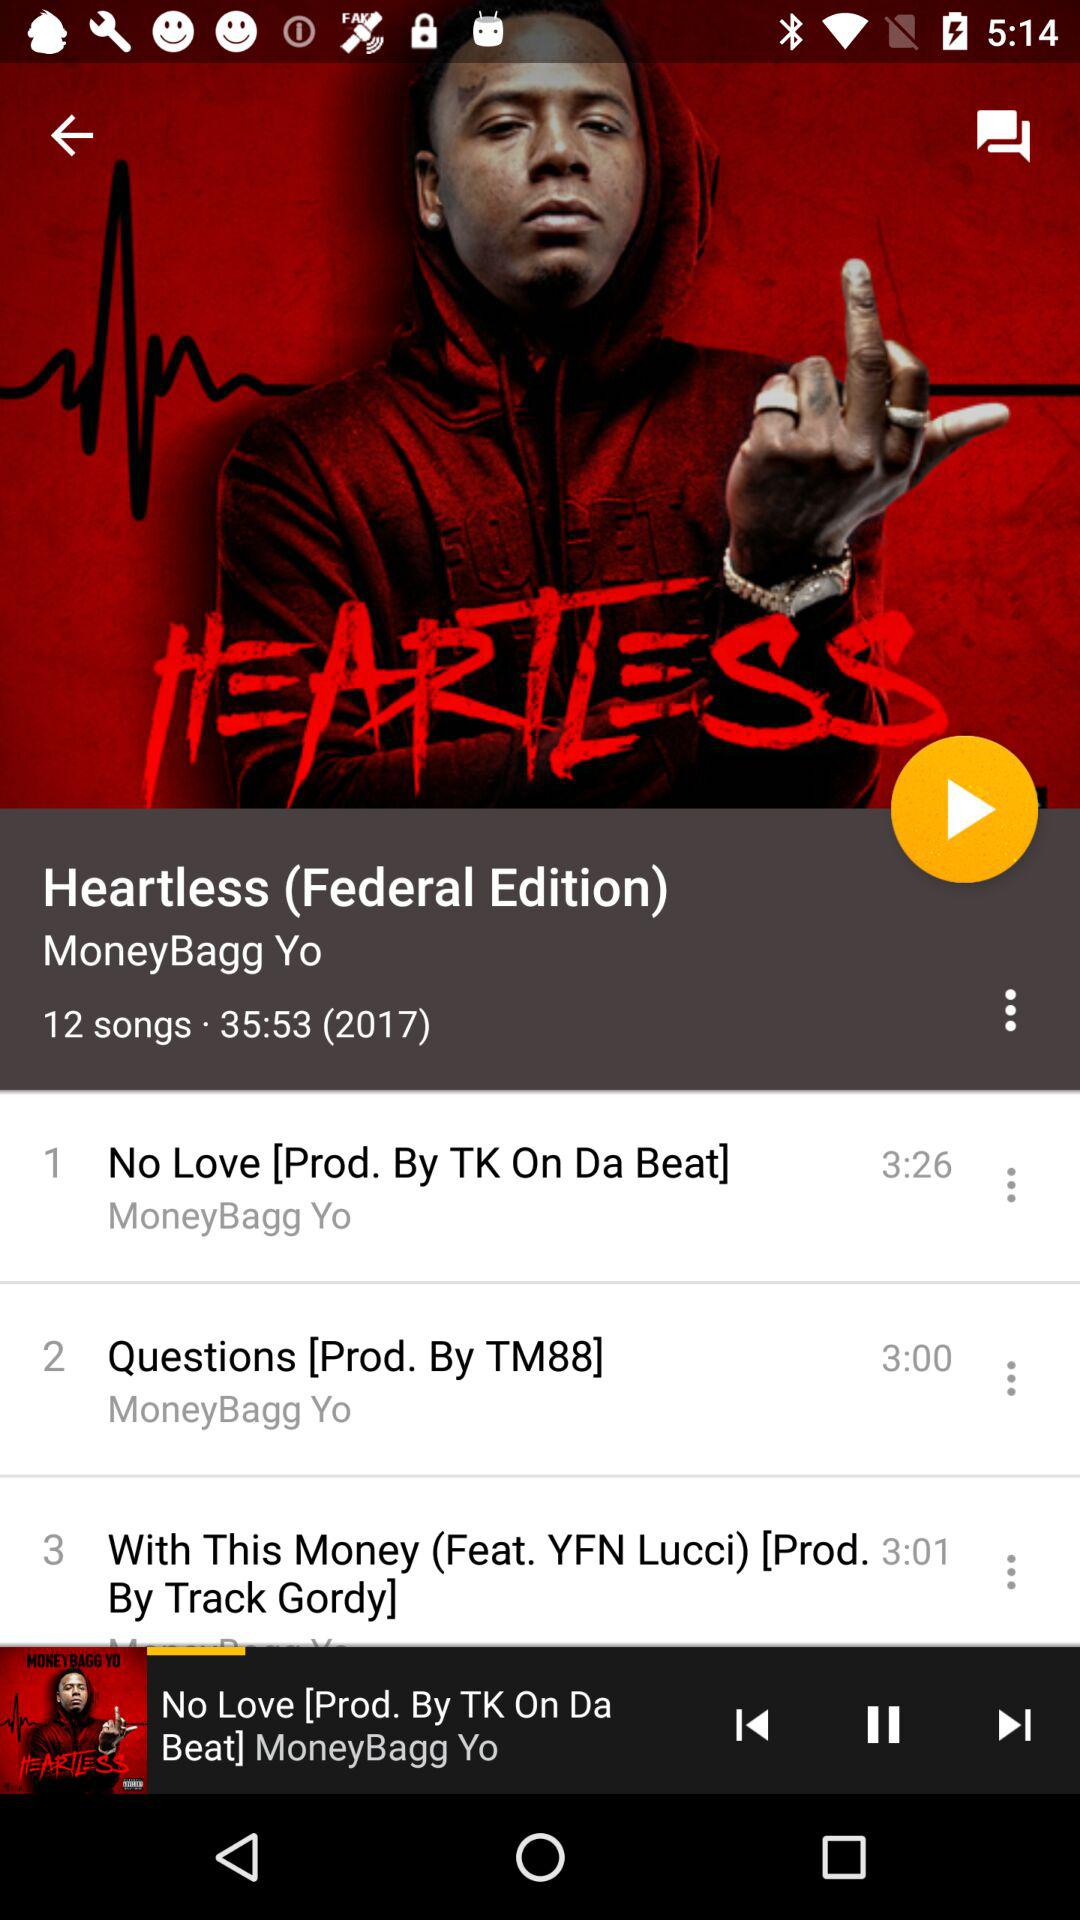Which song has the shortest duration?
When the provided information is insufficient, respond with <no answer>. <no answer> 